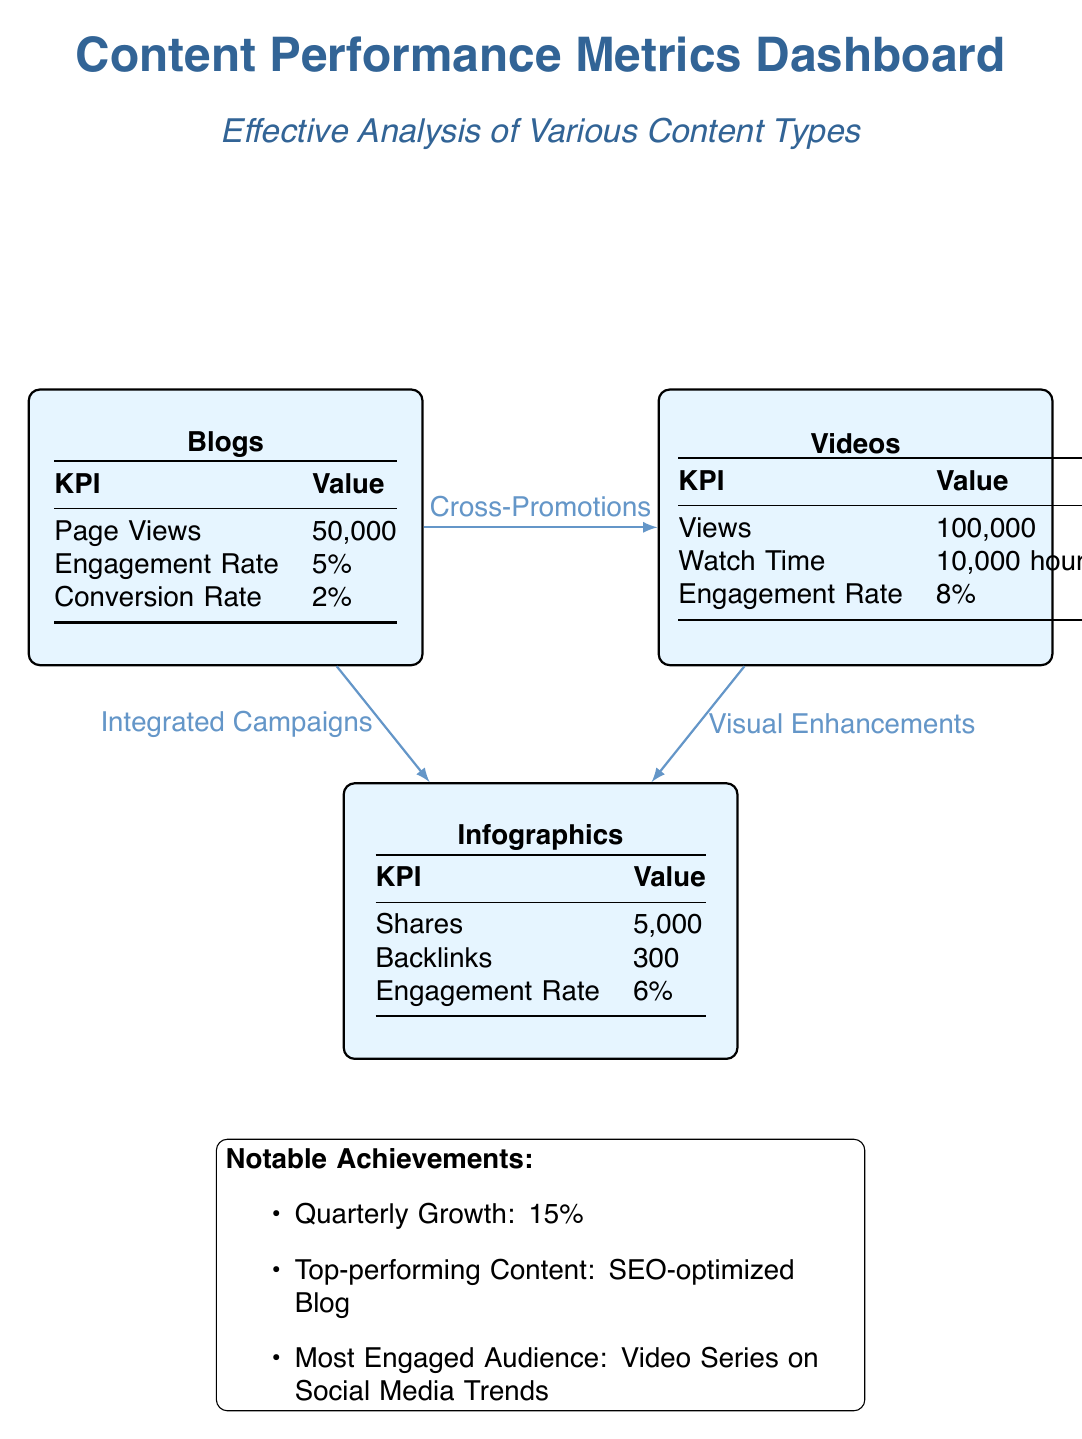What's the total number of KPIs displayed for Blogs? The Blogs node contains a table with three key performance indicators listed: Page Views, Engagement Rate, and Conversion Rate. Therefore, the total number of KPIs for Blogs is three.
Answer: 3 What is the Engagement Rate for Videos? In the Videos node, the Engagement Rate is clearly mentioned as 8%. This is a specific metric that measures how engaging the content is for the audience.
Answer: 8% Which content type has the highest number of views? The Videos node indicates a total of 100,000 views, which is higher than both Blogs (50,000 page views) and Infographics (not mentioned). Hence, Videos has the highest number of views.
Answer: Videos What notable achievement relates to the SEO-optimized Blog? The diagram highlights that the top-performing content is the SEO-optimized Blog. This indicates that among all content types, this specific blog has achieved significant success and is a point of pride.
Answer: Top-performing Content: SEO-optimized Blog How many shares were recorded for Infographics? The Infographics node lists the number of Shares as 5,000, which quantifies the level of engagement this type of content has achieved in terms of being shared by users.
Answer: 5,000 What is the relationship between Blogs and Infographics? The diagram indicates that Blogs and Infographics are connected through Integrated Campaigns. This suggests that strategies involving Blogs have a direct impact on the distribution or performance of Infographics.
Answer: Integrated Campaigns Which content type has the most hours of watch time according to the diagram? From the Videos node, it is specified that there is a total watch time of 10,000 hours. The other content types (Blogs and Infographics) do not specify watch time, making Videos the only one with watch time data.
Answer: Videos What percentage growth has been recorded quarterly? The notable achievements section states a Quarterly Growth of 15%. This percentage signifies the overall growth trend in terms of performance metrics across all content types.
Answer: 15% 